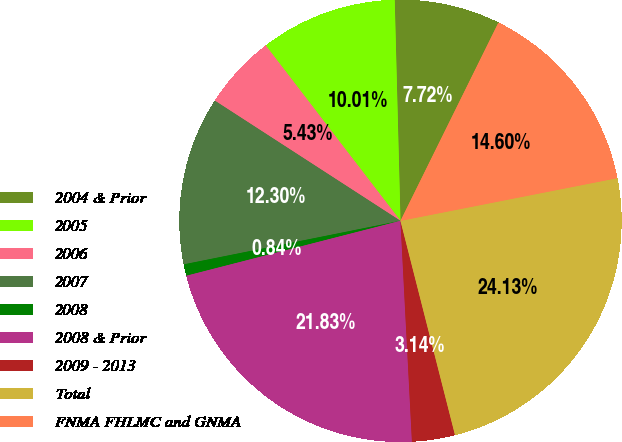Convert chart. <chart><loc_0><loc_0><loc_500><loc_500><pie_chart><fcel>2004 & Prior<fcel>2005<fcel>2006<fcel>2007<fcel>2008<fcel>2008 & Prior<fcel>2009 - 2013<fcel>Total<fcel>FNMA FHLMC and GNMA<nl><fcel>7.72%<fcel>10.01%<fcel>5.43%<fcel>12.3%<fcel>0.84%<fcel>21.83%<fcel>3.14%<fcel>24.13%<fcel>14.6%<nl></chart> 